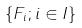Convert formula to latex. <formula><loc_0><loc_0><loc_500><loc_500>\{ F _ { i } ; i \in I \}</formula> 